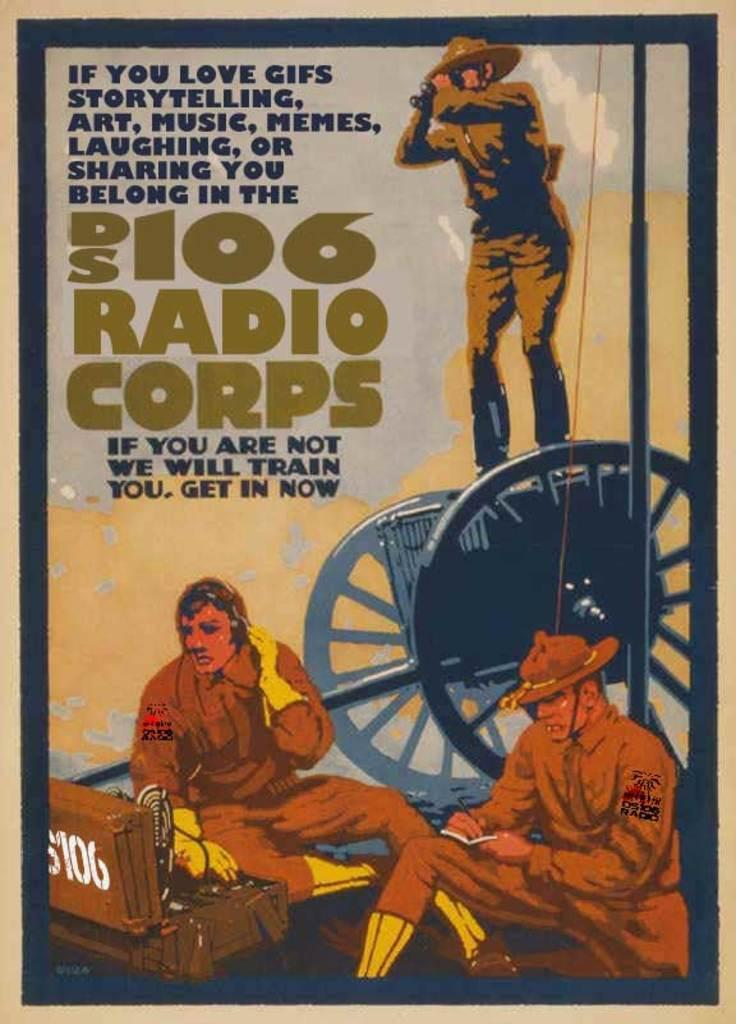<image>
Offer a succinct explanation of the picture presented. Radio corps sign for people who love art, music, 